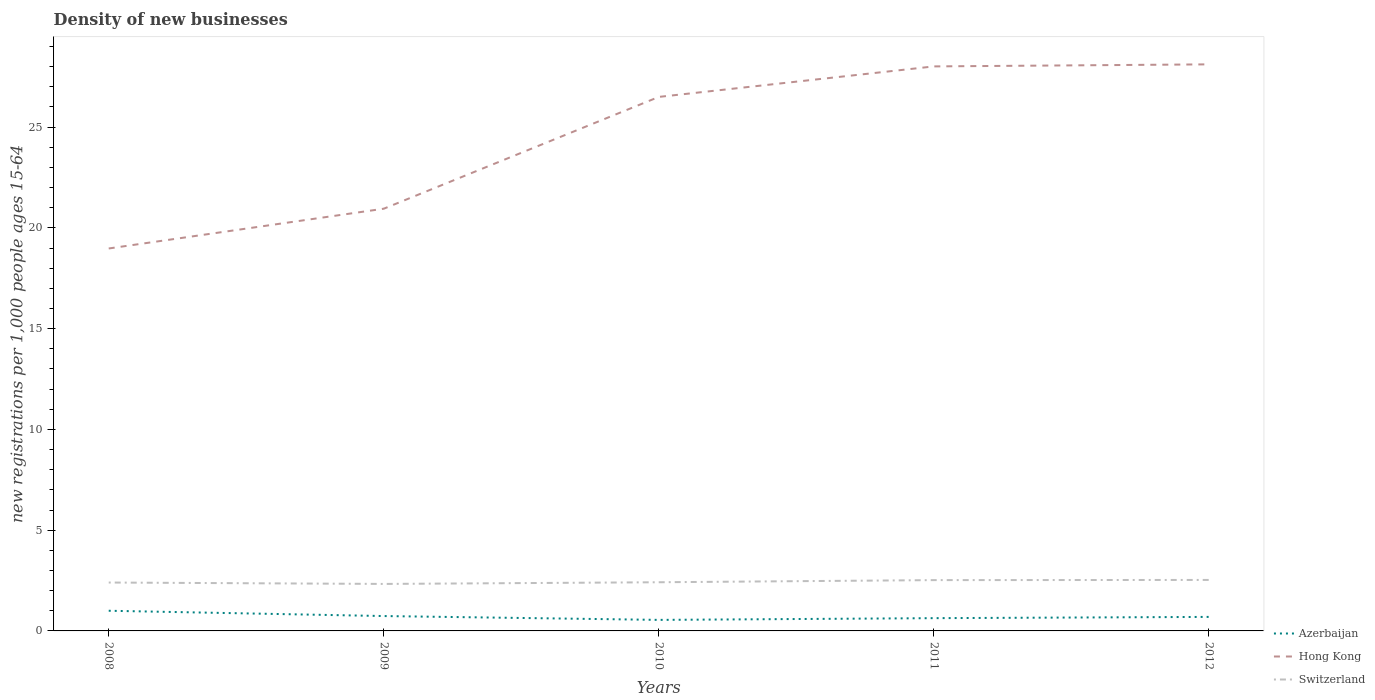How many different coloured lines are there?
Your answer should be very brief. 3. Is the number of lines equal to the number of legend labels?
Your answer should be compact. Yes. Across all years, what is the maximum number of new registrations in Azerbaijan?
Your answer should be very brief. 0.55. What is the total number of new registrations in Azerbaijan in the graph?
Give a very brief answer. 0.04. What is the difference between the highest and the second highest number of new registrations in Hong Kong?
Ensure brevity in your answer.  9.14. How many lines are there?
Ensure brevity in your answer.  3. Are the values on the major ticks of Y-axis written in scientific E-notation?
Provide a succinct answer. No. Where does the legend appear in the graph?
Offer a terse response. Bottom right. How are the legend labels stacked?
Your answer should be compact. Vertical. What is the title of the graph?
Your response must be concise. Density of new businesses. Does "Guam" appear as one of the legend labels in the graph?
Your answer should be compact. No. What is the label or title of the Y-axis?
Provide a succinct answer. New registrations per 1,0 people ages 15-64. What is the new registrations per 1,000 people ages 15-64 in Azerbaijan in 2008?
Offer a very short reply. 1. What is the new registrations per 1,000 people ages 15-64 in Hong Kong in 2008?
Offer a terse response. 18.98. What is the new registrations per 1,000 people ages 15-64 of Switzerland in 2008?
Offer a very short reply. 2.4. What is the new registrations per 1,000 people ages 15-64 of Azerbaijan in 2009?
Offer a terse response. 0.74. What is the new registrations per 1,000 people ages 15-64 of Hong Kong in 2009?
Your answer should be very brief. 20.95. What is the new registrations per 1,000 people ages 15-64 in Switzerland in 2009?
Your answer should be very brief. 2.33. What is the new registrations per 1,000 people ages 15-64 in Azerbaijan in 2010?
Your answer should be compact. 0.55. What is the new registrations per 1,000 people ages 15-64 of Hong Kong in 2010?
Your answer should be very brief. 26.5. What is the new registrations per 1,000 people ages 15-64 in Switzerland in 2010?
Keep it short and to the point. 2.42. What is the new registrations per 1,000 people ages 15-64 in Azerbaijan in 2011?
Make the answer very short. 0.63. What is the new registrations per 1,000 people ages 15-64 of Hong Kong in 2011?
Provide a succinct answer. 28.01. What is the new registrations per 1,000 people ages 15-64 in Switzerland in 2011?
Offer a terse response. 2.52. What is the new registrations per 1,000 people ages 15-64 of Azerbaijan in 2012?
Provide a short and direct response. 0.7. What is the new registrations per 1,000 people ages 15-64 in Hong Kong in 2012?
Give a very brief answer. 28.12. What is the new registrations per 1,000 people ages 15-64 of Switzerland in 2012?
Your answer should be compact. 2.53. Across all years, what is the maximum new registrations per 1,000 people ages 15-64 of Azerbaijan?
Your answer should be compact. 1. Across all years, what is the maximum new registrations per 1,000 people ages 15-64 in Hong Kong?
Provide a short and direct response. 28.12. Across all years, what is the maximum new registrations per 1,000 people ages 15-64 in Switzerland?
Offer a terse response. 2.53. Across all years, what is the minimum new registrations per 1,000 people ages 15-64 in Azerbaijan?
Offer a very short reply. 0.55. Across all years, what is the minimum new registrations per 1,000 people ages 15-64 in Hong Kong?
Ensure brevity in your answer.  18.98. Across all years, what is the minimum new registrations per 1,000 people ages 15-64 in Switzerland?
Provide a short and direct response. 2.33. What is the total new registrations per 1,000 people ages 15-64 of Azerbaijan in the graph?
Provide a short and direct response. 3.62. What is the total new registrations per 1,000 people ages 15-64 in Hong Kong in the graph?
Ensure brevity in your answer.  122.56. What is the total new registrations per 1,000 people ages 15-64 in Switzerland in the graph?
Ensure brevity in your answer.  12.2. What is the difference between the new registrations per 1,000 people ages 15-64 in Azerbaijan in 2008 and that in 2009?
Provide a succinct answer. 0.26. What is the difference between the new registrations per 1,000 people ages 15-64 of Hong Kong in 2008 and that in 2009?
Offer a very short reply. -1.97. What is the difference between the new registrations per 1,000 people ages 15-64 of Switzerland in 2008 and that in 2009?
Offer a terse response. 0.07. What is the difference between the new registrations per 1,000 people ages 15-64 in Azerbaijan in 2008 and that in 2010?
Provide a succinct answer. 0.45. What is the difference between the new registrations per 1,000 people ages 15-64 in Hong Kong in 2008 and that in 2010?
Give a very brief answer. -7.52. What is the difference between the new registrations per 1,000 people ages 15-64 in Switzerland in 2008 and that in 2010?
Give a very brief answer. -0.01. What is the difference between the new registrations per 1,000 people ages 15-64 in Azerbaijan in 2008 and that in 2011?
Make the answer very short. 0.37. What is the difference between the new registrations per 1,000 people ages 15-64 in Hong Kong in 2008 and that in 2011?
Provide a succinct answer. -9.04. What is the difference between the new registrations per 1,000 people ages 15-64 in Switzerland in 2008 and that in 2011?
Provide a succinct answer. -0.12. What is the difference between the new registrations per 1,000 people ages 15-64 in Azerbaijan in 2008 and that in 2012?
Your answer should be compact. 0.31. What is the difference between the new registrations per 1,000 people ages 15-64 of Hong Kong in 2008 and that in 2012?
Provide a short and direct response. -9.14. What is the difference between the new registrations per 1,000 people ages 15-64 of Switzerland in 2008 and that in 2012?
Offer a terse response. -0.13. What is the difference between the new registrations per 1,000 people ages 15-64 of Azerbaijan in 2009 and that in 2010?
Your answer should be compact. 0.19. What is the difference between the new registrations per 1,000 people ages 15-64 of Hong Kong in 2009 and that in 2010?
Your answer should be compact. -5.55. What is the difference between the new registrations per 1,000 people ages 15-64 of Switzerland in 2009 and that in 2010?
Provide a short and direct response. -0.08. What is the difference between the new registrations per 1,000 people ages 15-64 in Azerbaijan in 2009 and that in 2011?
Offer a very short reply. 0.1. What is the difference between the new registrations per 1,000 people ages 15-64 in Hong Kong in 2009 and that in 2011?
Keep it short and to the point. -7.06. What is the difference between the new registrations per 1,000 people ages 15-64 of Switzerland in 2009 and that in 2011?
Provide a succinct answer. -0.19. What is the difference between the new registrations per 1,000 people ages 15-64 in Azerbaijan in 2009 and that in 2012?
Ensure brevity in your answer.  0.04. What is the difference between the new registrations per 1,000 people ages 15-64 of Hong Kong in 2009 and that in 2012?
Provide a short and direct response. -7.16. What is the difference between the new registrations per 1,000 people ages 15-64 of Switzerland in 2009 and that in 2012?
Offer a terse response. -0.2. What is the difference between the new registrations per 1,000 people ages 15-64 in Azerbaijan in 2010 and that in 2011?
Give a very brief answer. -0.09. What is the difference between the new registrations per 1,000 people ages 15-64 of Hong Kong in 2010 and that in 2011?
Make the answer very short. -1.51. What is the difference between the new registrations per 1,000 people ages 15-64 in Switzerland in 2010 and that in 2011?
Provide a succinct answer. -0.11. What is the difference between the new registrations per 1,000 people ages 15-64 of Azerbaijan in 2010 and that in 2012?
Your response must be concise. -0.15. What is the difference between the new registrations per 1,000 people ages 15-64 of Hong Kong in 2010 and that in 2012?
Provide a short and direct response. -1.62. What is the difference between the new registrations per 1,000 people ages 15-64 of Switzerland in 2010 and that in 2012?
Keep it short and to the point. -0.11. What is the difference between the new registrations per 1,000 people ages 15-64 in Azerbaijan in 2011 and that in 2012?
Offer a terse response. -0.06. What is the difference between the new registrations per 1,000 people ages 15-64 in Hong Kong in 2011 and that in 2012?
Provide a succinct answer. -0.1. What is the difference between the new registrations per 1,000 people ages 15-64 in Switzerland in 2011 and that in 2012?
Provide a succinct answer. -0.01. What is the difference between the new registrations per 1,000 people ages 15-64 of Azerbaijan in 2008 and the new registrations per 1,000 people ages 15-64 of Hong Kong in 2009?
Your answer should be compact. -19.95. What is the difference between the new registrations per 1,000 people ages 15-64 in Azerbaijan in 2008 and the new registrations per 1,000 people ages 15-64 in Switzerland in 2009?
Your response must be concise. -1.33. What is the difference between the new registrations per 1,000 people ages 15-64 in Hong Kong in 2008 and the new registrations per 1,000 people ages 15-64 in Switzerland in 2009?
Your answer should be compact. 16.65. What is the difference between the new registrations per 1,000 people ages 15-64 in Azerbaijan in 2008 and the new registrations per 1,000 people ages 15-64 in Hong Kong in 2010?
Provide a succinct answer. -25.5. What is the difference between the new registrations per 1,000 people ages 15-64 of Azerbaijan in 2008 and the new registrations per 1,000 people ages 15-64 of Switzerland in 2010?
Make the answer very short. -1.41. What is the difference between the new registrations per 1,000 people ages 15-64 of Hong Kong in 2008 and the new registrations per 1,000 people ages 15-64 of Switzerland in 2010?
Your response must be concise. 16.56. What is the difference between the new registrations per 1,000 people ages 15-64 of Azerbaijan in 2008 and the new registrations per 1,000 people ages 15-64 of Hong Kong in 2011?
Keep it short and to the point. -27.01. What is the difference between the new registrations per 1,000 people ages 15-64 of Azerbaijan in 2008 and the new registrations per 1,000 people ages 15-64 of Switzerland in 2011?
Your response must be concise. -1.52. What is the difference between the new registrations per 1,000 people ages 15-64 in Hong Kong in 2008 and the new registrations per 1,000 people ages 15-64 in Switzerland in 2011?
Your answer should be very brief. 16.46. What is the difference between the new registrations per 1,000 people ages 15-64 in Azerbaijan in 2008 and the new registrations per 1,000 people ages 15-64 in Hong Kong in 2012?
Your answer should be compact. -27.11. What is the difference between the new registrations per 1,000 people ages 15-64 in Azerbaijan in 2008 and the new registrations per 1,000 people ages 15-64 in Switzerland in 2012?
Keep it short and to the point. -1.53. What is the difference between the new registrations per 1,000 people ages 15-64 in Hong Kong in 2008 and the new registrations per 1,000 people ages 15-64 in Switzerland in 2012?
Your answer should be compact. 16.45. What is the difference between the new registrations per 1,000 people ages 15-64 in Azerbaijan in 2009 and the new registrations per 1,000 people ages 15-64 in Hong Kong in 2010?
Keep it short and to the point. -25.76. What is the difference between the new registrations per 1,000 people ages 15-64 in Azerbaijan in 2009 and the new registrations per 1,000 people ages 15-64 in Switzerland in 2010?
Give a very brief answer. -1.68. What is the difference between the new registrations per 1,000 people ages 15-64 in Hong Kong in 2009 and the new registrations per 1,000 people ages 15-64 in Switzerland in 2010?
Your answer should be very brief. 18.54. What is the difference between the new registrations per 1,000 people ages 15-64 in Azerbaijan in 2009 and the new registrations per 1,000 people ages 15-64 in Hong Kong in 2011?
Offer a very short reply. -27.28. What is the difference between the new registrations per 1,000 people ages 15-64 in Azerbaijan in 2009 and the new registrations per 1,000 people ages 15-64 in Switzerland in 2011?
Provide a short and direct response. -1.78. What is the difference between the new registrations per 1,000 people ages 15-64 of Hong Kong in 2009 and the new registrations per 1,000 people ages 15-64 of Switzerland in 2011?
Your response must be concise. 18.43. What is the difference between the new registrations per 1,000 people ages 15-64 in Azerbaijan in 2009 and the new registrations per 1,000 people ages 15-64 in Hong Kong in 2012?
Keep it short and to the point. -27.38. What is the difference between the new registrations per 1,000 people ages 15-64 in Azerbaijan in 2009 and the new registrations per 1,000 people ages 15-64 in Switzerland in 2012?
Your answer should be compact. -1.79. What is the difference between the new registrations per 1,000 people ages 15-64 in Hong Kong in 2009 and the new registrations per 1,000 people ages 15-64 in Switzerland in 2012?
Provide a short and direct response. 18.42. What is the difference between the new registrations per 1,000 people ages 15-64 in Azerbaijan in 2010 and the new registrations per 1,000 people ages 15-64 in Hong Kong in 2011?
Provide a succinct answer. -27.47. What is the difference between the new registrations per 1,000 people ages 15-64 in Azerbaijan in 2010 and the new registrations per 1,000 people ages 15-64 in Switzerland in 2011?
Make the answer very short. -1.97. What is the difference between the new registrations per 1,000 people ages 15-64 in Hong Kong in 2010 and the new registrations per 1,000 people ages 15-64 in Switzerland in 2011?
Your response must be concise. 23.98. What is the difference between the new registrations per 1,000 people ages 15-64 in Azerbaijan in 2010 and the new registrations per 1,000 people ages 15-64 in Hong Kong in 2012?
Make the answer very short. -27.57. What is the difference between the new registrations per 1,000 people ages 15-64 in Azerbaijan in 2010 and the new registrations per 1,000 people ages 15-64 in Switzerland in 2012?
Make the answer very short. -1.98. What is the difference between the new registrations per 1,000 people ages 15-64 of Hong Kong in 2010 and the new registrations per 1,000 people ages 15-64 of Switzerland in 2012?
Give a very brief answer. 23.97. What is the difference between the new registrations per 1,000 people ages 15-64 in Azerbaijan in 2011 and the new registrations per 1,000 people ages 15-64 in Hong Kong in 2012?
Offer a very short reply. -27.48. What is the difference between the new registrations per 1,000 people ages 15-64 of Azerbaijan in 2011 and the new registrations per 1,000 people ages 15-64 of Switzerland in 2012?
Give a very brief answer. -1.9. What is the difference between the new registrations per 1,000 people ages 15-64 in Hong Kong in 2011 and the new registrations per 1,000 people ages 15-64 in Switzerland in 2012?
Provide a succinct answer. 25.48. What is the average new registrations per 1,000 people ages 15-64 of Azerbaijan per year?
Make the answer very short. 0.72. What is the average new registrations per 1,000 people ages 15-64 of Hong Kong per year?
Provide a short and direct response. 24.51. What is the average new registrations per 1,000 people ages 15-64 of Switzerland per year?
Offer a very short reply. 2.44. In the year 2008, what is the difference between the new registrations per 1,000 people ages 15-64 of Azerbaijan and new registrations per 1,000 people ages 15-64 of Hong Kong?
Give a very brief answer. -17.98. In the year 2008, what is the difference between the new registrations per 1,000 people ages 15-64 in Azerbaijan and new registrations per 1,000 people ages 15-64 in Switzerland?
Your response must be concise. -1.4. In the year 2008, what is the difference between the new registrations per 1,000 people ages 15-64 of Hong Kong and new registrations per 1,000 people ages 15-64 of Switzerland?
Make the answer very short. 16.58. In the year 2009, what is the difference between the new registrations per 1,000 people ages 15-64 in Azerbaijan and new registrations per 1,000 people ages 15-64 in Hong Kong?
Your answer should be very brief. -20.21. In the year 2009, what is the difference between the new registrations per 1,000 people ages 15-64 of Azerbaijan and new registrations per 1,000 people ages 15-64 of Switzerland?
Give a very brief answer. -1.59. In the year 2009, what is the difference between the new registrations per 1,000 people ages 15-64 of Hong Kong and new registrations per 1,000 people ages 15-64 of Switzerland?
Your answer should be very brief. 18.62. In the year 2010, what is the difference between the new registrations per 1,000 people ages 15-64 of Azerbaijan and new registrations per 1,000 people ages 15-64 of Hong Kong?
Offer a very short reply. -25.95. In the year 2010, what is the difference between the new registrations per 1,000 people ages 15-64 in Azerbaijan and new registrations per 1,000 people ages 15-64 in Switzerland?
Make the answer very short. -1.87. In the year 2010, what is the difference between the new registrations per 1,000 people ages 15-64 in Hong Kong and new registrations per 1,000 people ages 15-64 in Switzerland?
Your response must be concise. 24.08. In the year 2011, what is the difference between the new registrations per 1,000 people ages 15-64 in Azerbaijan and new registrations per 1,000 people ages 15-64 in Hong Kong?
Provide a short and direct response. -27.38. In the year 2011, what is the difference between the new registrations per 1,000 people ages 15-64 of Azerbaijan and new registrations per 1,000 people ages 15-64 of Switzerland?
Your answer should be very brief. -1.89. In the year 2011, what is the difference between the new registrations per 1,000 people ages 15-64 of Hong Kong and new registrations per 1,000 people ages 15-64 of Switzerland?
Your answer should be very brief. 25.49. In the year 2012, what is the difference between the new registrations per 1,000 people ages 15-64 in Azerbaijan and new registrations per 1,000 people ages 15-64 in Hong Kong?
Your answer should be compact. -27.42. In the year 2012, what is the difference between the new registrations per 1,000 people ages 15-64 of Azerbaijan and new registrations per 1,000 people ages 15-64 of Switzerland?
Your answer should be compact. -1.83. In the year 2012, what is the difference between the new registrations per 1,000 people ages 15-64 of Hong Kong and new registrations per 1,000 people ages 15-64 of Switzerland?
Your answer should be compact. 25.59. What is the ratio of the new registrations per 1,000 people ages 15-64 in Azerbaijan in 2008 to that in 2009?
Make the answer very short. 1.36. What is the ratio of the new registrations per 1,000 people ages 15-64 of Hong Kong in 2008 to that in 2009?
Offer a very short reply. 0.91. What is the ratio of the new registrations per 1,000 people ages 15-64 of Switzerland in 2008 to that in 2009?
Offer a very short reply. 1.03. What is the ratio of the new registrations per 1,000 people ages 15-64 in Azerbaijan in 2008 to that in 2010?
Provide a succinct answer. 1.83. What is the ratio of the new registrations per 1,000 people ages 15-64 in Hong Kong in 2008 to that in 2010?
Your response must be concise. 0.72. What is the ratio of the new registrations per 1,000 people ages 15-64 in Azerbaijan in 2008 to that in 2011?
Offer a terse response. 1.58. What is the ratio of the new registrations per 1,000 people ages 15-64 of Hong Kong in 2008 to that in 2011?
Offer a very short reply. 0.68. What is the ratio of the new registrations per 1,000 people ages 15-64 in Azerbaijan in 2008 to that in 2012?
Offer a terse response. 1.44. What is the ratio of the new registrations per 1,000 people ages 15-64 of Hong Kong in 2008 to that in 2012?
Your response must be concise. 0.68. What is the ratio of the new registrations per 1,000 people ages 15-64 in Switzerland in 2008 to that in 2012?
Offer a terse response. 0.95. What is the ratio of the new registrations per 1,000 people ages 15-64 in Azerbaijan in 2009 to that in 2010?
Ensure brevity in your answer.  1.35. What is the ratio of the new registrations per 1,000 people ages 15-64 in Hong Kong in 2009 to that in 2010?
Keep it short and to the point. 0.79. What is the ratio of the new registrations per 1,000 people ages 15-64 in Switzerland in 2009 to that in 2010?
Ensure brevity in your answer.  0.97. What is the ratio of the new registrations per 1,000 people ages 15-64 of Azerbaijan in 2009 to that in 2011?
Provide a succinct answer. 1.17. What is the ratio of the new registrations per 1,000 people ages 15-64 of Hong Kong in 2009 to that in 2011?
Your answer should be compact. 0.75. What is the ratio of the new registrations per 1,000 people ages 15-64 of Switzerland in 2009 to that in 2011?
Your answer should be very brief. 0.92. What is the ratio of the new registrations per 1,000 people ages 15-64 in Azerbaijan in 2009 to that in 2012?
Offer a very short reply. 1.06. What is the ratio of the new registrations per 1,000 people ages 15-64 in Hong Kong in 2009 to that in 2012?
Keep it short and to the point. 0.75. What is the ratio of the new registrations per 1,000 people ages 15-64 of Switzerland in 2009 to that in 2012?
Your answer should be compact. 0.92. What is the ratio of the new registrations per 1,000 people ages 15-64 in Azerbaijan in 2010 to that in 2011?
Keep it short and to the point. 0.86. What is the ratio of the new registrations per 1,000 people ages 15-64 in Hong Kong in 2010 to that in 2011?
Your answer should be very brief. 0.95. What is the ratio of the new registrations per 1,000 people ages 15-64 of Switzerland in 2010 to that in 2011?
Offer a terse response. 0.96. What is the ratio of the new registrations per 1,000 people ages 15-64 in Azerbaijan in 2010 to that in 2012?
Provide a short and direct response. 0.79. What is the ratio of the new registrations per 1,000 people ages 15-64 in Hong Kong in 2010 to that in 2012?
Your response must be concise. 0.94. What is the ratio of the new registrations per 1,000 people ages 15-64 in Switzerland in 2010 to that in 2012?
Your response must be concise. 0.95. What is the ratio of the new registrations per 1,000 people ages 15-64 of Azerbaijan in 2011 to that in 2012?
Offer a very short reply. 0.91. What is the ratio of the new registrations per 1,000 people ages 15-64 in Hong Kong in 2011 to that in 2012?
Give a very brief answer. 1. What is the difference between the highest and the second highest new registrations per 1,000 people ages 15-64 of Azerbaijan?
Provide a short and direct response. 0.26. What is the difference between the highest and the second highest new registrations per 1,000 people ages 15-64 of Hong Kong?
Your answer should be very brief. 0.1. What is the difference between the highest and the second highest new registrations per 1,000 people ages 15-64 in Switzerland?
Ensure brevity in your answer.  0.01. What is the difference between the highest and the lowest new registrations per 1,000 people ages 15-64 of Azerbaijan?
Your answer should be compact. 0.45. What is the difference between the highest and the lowest new registrations per 1,000 people ages 15-64 of Hong Kong?
Your answer should be very brief. 9.14. What is the difference between the highest and the lowest new registrations per 1,000 people ages 15-64 of Switzerland?
Provide a short and direct response. 0.2. 